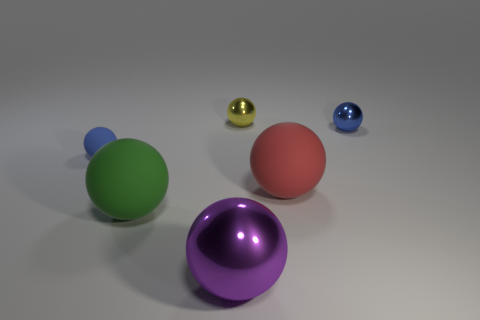Are there any tiny metallic things that have the same color as the small rubber thing?
Your response must be concise. Yes. Are there any shiny things that are behind the large red object that is in front of the tiny blue shiny sphere?
Provide a short and direct response. Yes. What number of other objects are there of the same color as the small matte thing?
Provide a short and direct response. 1. The tiny rubber thing has what color?
Offer a terse response. Blue. How big is the thing that is behind the large red ball and to the left of the small yellow metallic sphere?
Ensure brevity in your answer.  Small. How many things are shiny balls behind the small matte object or big green objects?
Provide a short and direct response. 3. There is a tiny object that is made of the same material as the yellow sphere; what shape is it?
Your response must be concise. Sphere. The small blue rubber object has what shape?
Keep it short and to the point. Sphere. There is a object that is both in front of the small rubber ball and to the right of the big metal ball; what is its color?
Provide a succinct answer. Red. Are there any tiny blue things that have the same shape as the small yellow thing?
Make the answer very short. Yes. 